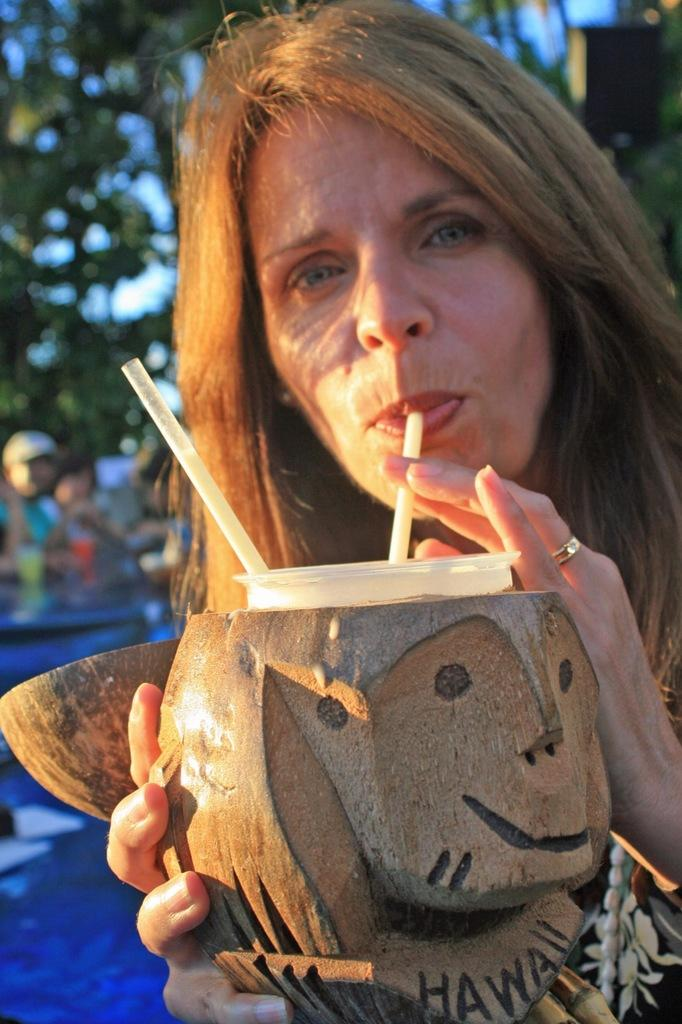Who is the main subject in the image? There is a lady in the image. What is the lady holding in the image? The lady is holding an object. What is the lady doing with the liquid in the image? The lady is drinking a liquid. What can be seen in the background of the image? There are people and trees in the background of the image. What type of plant is the lady watering with the pail in the image? There is no plant or pail present in the image. What is the lady's occupation as a secretary in the image? There is no indication of the lady's occupation in the image. 